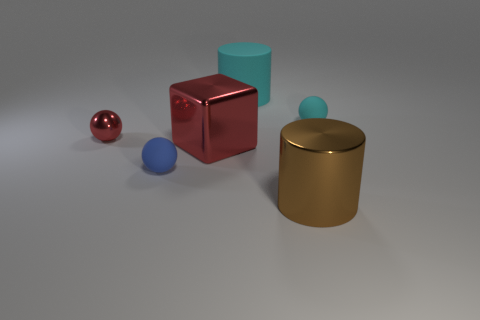How many small cyan objects are the same shape as the large brown object?
Give a very brief answer. 0. Is the number of cyan matte objects that are behind the large cyan cylinder the same as the number of blue shiny cylinders?
Your response must be concise. Yes. There is a cube that is the same size as the brown metallic object; what is its color?
Keep it short and to the point. Red. Is there another tiny cyan shiny thing of the same shape as the small metal object?
Ensure brevity in your answer.  No. There is a cyan object that is left of the tiny ball on the right side of the small matte thing on the left side of the large matte thing; what is it made of?
Provide a succinct answer. Rubber. Are there the same number of tiny blue balls and big blue objects?
Your answer should be compact. No. How many other things are there of the same size as the cyan cylinder?
Give a very brief answer. 2. What color is the metallic sphere?
Your answer should be very brief. Red. What number of rubber objects are big cyan cylinders or tiny red cylinders?
Your response must be concise. 1. Are there any other things that have the same material as the red block?
Offer a very short reply. Yes. 